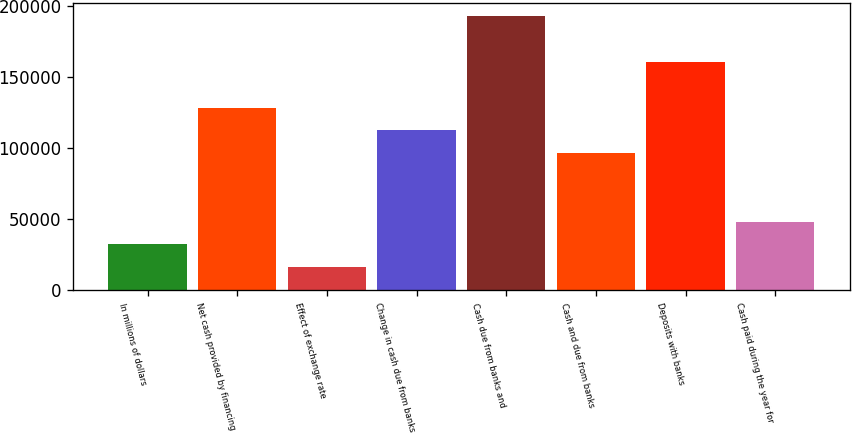<chart> <loc_0><loc_0><loc_500><loc_500><bar_chart><fcel>In millions of dollars<fcel>Net cash provided by financing<fcel>Effect of exchange rate<fcel>Change in cash due from banks<fcel>Cash due from banks and<fcel>Cash and due from banks<fcel>Deposits with banks<fcel>Cash paid during the year for<nl><fcel>32230.8<fcel>128428<fcel>16197.9<fcel>112395<fcel>192560<fcel>96362.4<fcel>160494<fcel>48263.7<nl></chart> 